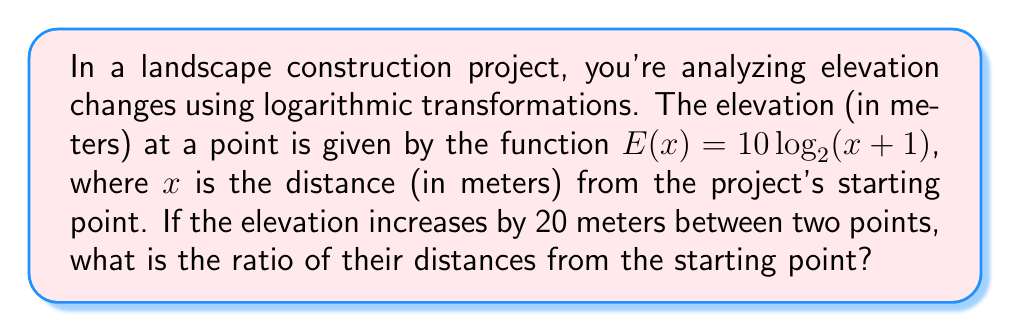Could you help me with this problem? Let's approach this step-by-step:

1) Let the two points be at distances $x_1$ and $x_2$ from the starting point.

2) The elevation at $x_1$ is $E(x_1) = 10 \log_{2}(x_1 + 1)$
   The elevation at $x_2$ is $E(x_2) = 10 \log_{2}(x_2 + 1)$

3) We're told that the elevation increases by 20 meters, so:
   $E(x_2) - E(x_1) = 20$

4) Substituting the expressions from step 2:
   $10 \log_{2}(x_2 + 1) - 10 \log_{2}(x_1 + 1) = 20$

5) Dividing both sides by 10:
   $\log_{2}(x_2 + 1) - \log_{2}(x_1 + 1) = 2$

6) Using the logarithm subtraction rule:
   $\log_{2}(\frac{x_2 + 1}{x_1 + 1}) = 2$

7) Applying $2^x$ to both sides:
   $\frac{x_2 + 1}{x_1 + 1} = 2^2 = 4$

8) Therefore, $\frac{x_2 + 1}{x_1 + 1} = 4$

9) To find the ratio of distances, we need $\frac{x_2}{x_1}$:
   $\frac{x_2}{x_1} = \frac{4(x_1 + 1) - 1}{x_1} = \frac{4x_1 + 3}{x_1} = 4 + \frac{3}{x_1}$

10) As $x_1$ increases, $\frac{3}{x_1}$ approaches 0, so the ratio $\frac{x_2}{x_1}$ approaches 4.
Answer: 4 